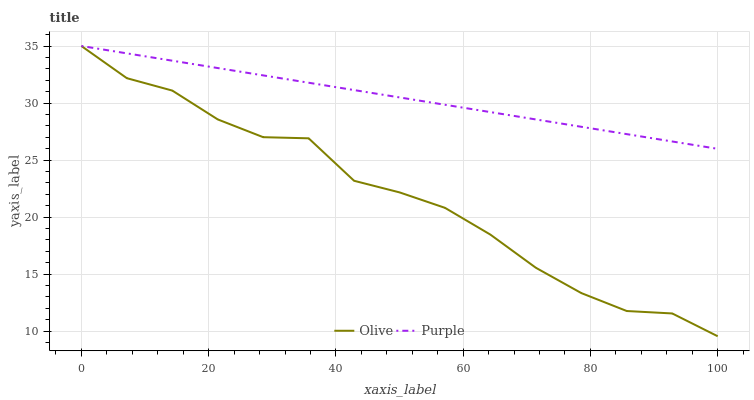Does Purple have the minimum area under the curve?
Answer yes or no. No. Is Purple the roughest?
Answer yes or no. No. Does Purple have the lowest value?
Answer yes or no. No. 